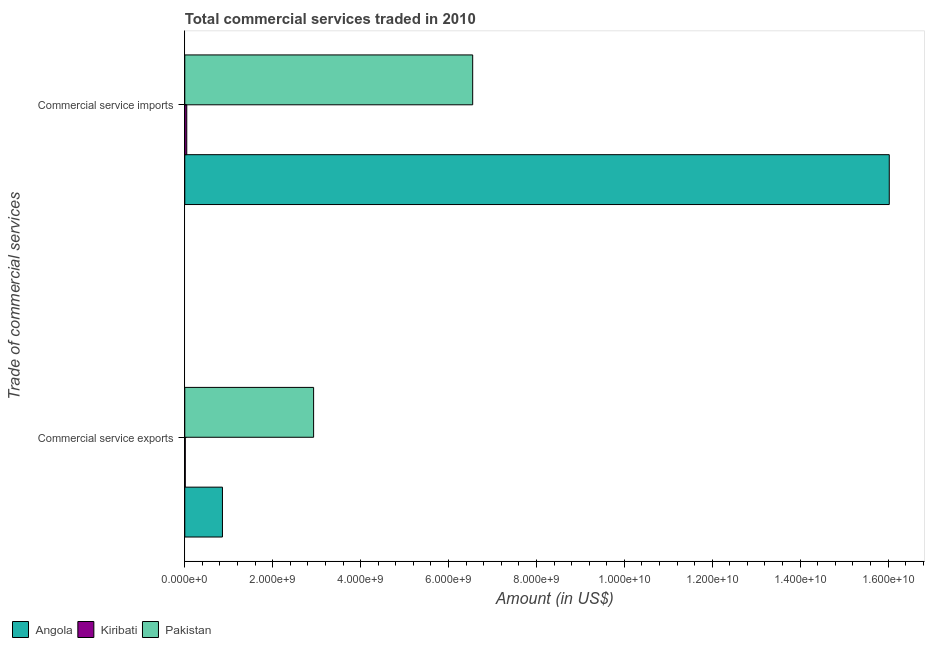How many different coloured bars are there?
Provide a short and direct response. 3. How many groups of bars are there?
Ensure brevity in your answer.  2. Are the number of bars per tick equal to the number of legend labels?
Your answer should be compact. Yes. How many bars are there on the 1st tick from the top?
Ensure brevity in your answer.  3. How many bars are there on the 2nd tick from the bottom?
Ensure brevity in your answer.  3. What is the label of the 2nd group of bars from the top?
Your answer should be very brief. Commercial service exports. What is the amount of commercial service exports in Pakistan?
Give a very brief answer. 2.93e+09. Across all countries, what is the maximum amount of commercial service imports?
Provide a succinct answer. 1.60e+1. Across all countries, what is the minimum amount of commercial service exports?
Ensure brevity in your answer.  1.10e+07. In which country was the amount of commercial service exports maximum?
Ensure brevity in your answer.  Pakistan. In which country was the amount of commercial service exports minimum?
Keep it short and to the point. Kiribati. What is the total amount of commercial service imports in the graph?
Provide a succinct answer. 2.26e+1. What is the difference between the amount of commercial service exports in Pakistan and that in Kiribati?
Your answer should be compact. 2.92e+09. What is the difference between the amount of commercial service imports in Pakistan and the amount of commercial service exports in Angola?
Your response must be concise. 5.69e+09. What is the average amount of commercial service imports per country?
Keep it short and to the point. 7.54e+09. What is the difference between the amount of commercial service imports and amount of commercial service exports in Pakistan?
Your answer should be very brief. 3.62e+09. What is the ratio of the amount of commercial service imports in Angola to that in Pakistan?
Provide a short and direct response. 2.45. In how many countries, is the amount of commercial service imports greater than the average amount of commercial service imports taken over all countries?
Keep it short and to the point. 1. What does the 1st bar from the top in Commercial service exports represents?
Offer a very short reply. Pakistan. What does the 1st bar from the bottom in Commercial service exports represents?
Your response must be concise. Angola. How many bars are there?
Give a very brief answer. 6. Are the values on the major ticks of X-axis written in scientific E-notation?
Provide a succinct answer. Yes. Does the graph contain grids?
Provide a short and direct response. No. Where does the legend appear in the graph?
Your answer should be very brief. Bottom left. How many legend labels are there?
Provide a succinct answer. 3. How are the legend labels stacked?
Keep it short and to the point. Horizontal. What is the title of the graph?
Give a very brief answer. Total commercial services traded in 2010. Does "El Salvador" appear as one of the legend labels in the graph?
Ensure brevity in your answer.  No. What is the label or title of the Y-axis?
Your answer should be very brief. Trade of commercial services. What is the Amount (in US$) of Angola in Commercial service exports?
Your answer should be very brief. 8.57e+08. What is the Amount (in US$) of Kiribati in Commercial service exports?
Your response must be concise. 1.10e+07. What is the Amount (in US$) of Pakistan in Commercial service exports?
Your response must be concise. 2.93e+09. What is the Amount (in US$) in Angola in Commercial service imports?
Give a very brief answer. 1.60e+1. What is the Amount (in US$) of Kiribati in Commercial service imports?
Ensure brevity in your answer.  4.50e+07. What is the Amount (in US$) of Pakistan in Commercial service imports?
Offer a terse response. 6.55e+09. Across all Trade of commercial services, what is the maximum Amount (in US$) in Angola?
Provide a short and direct response. 1.60e+1. Across all Trade of commercial services, what is the maximum Amount (in US$) in Kiribati?
Your answer should be very brief. 4.50e+07. Across all Trade of commercial services, what is the maximum Amount (in US$) of Pakistan?
Provide a succinct answer. 6.55e+09. Across all Trade of commercial services, what is the minimum Amount (in US$) of Angola?
Give a very brief answer. 8.57e+08. Across all Trade of commercial services, what is the minimum Amount (in US$) in Kiribati?
Your answer should be very brief. 1.10e+07. Across all Trade of commercial services, what is the minimum Amount (in US$) in Pakistan?
Your response must be concise. 2.93e+09. What is the total Amount (in US$) of Angola in the graph?
Provide a short and direct response. 1.69e+1. What is the total Amount (in US$) in Kiribati in the graph?
Keep it short and to the point. 5.60e+07. What is the total Amount (in US$) in Pakistan in the graph?
Your answer should be compact. 9.48e+09. What is the difference between the Amount (in US$) in Angola in Commercial service exports and that in Commercial service imports?
Provide a succinct answer. -1.52e+1. What is the difference between the Amount (in US$) of Kiribati in Commercial service exports and that in Commercial service imports?
Keep it short and to the point. -3.41e+07. What is the difference between the Amount (in US$) in Pakistan in Commercial service exports and that in Commercial service imports?
Provide a short and direct response. -3.62e+09. What is the difference between the Amount (in US$) in Angola in Commercial service exports and the Amount (in US$) in Kiribati in Commercial service imports?
Your answer should be compact. 8.12e+08. What is the difference between the Amount (in US$) of Angola in Commercial service exports and the Amount (in US$) of Pakistan in Commercial service imports?
Offer a terse response. -5.69e+09. What is the difference between the Amount (in US$) in Kiribati in Commercial service exports and the Amount (in US$) in Pakistan in Commercial service imports?
Your response must be concise. -6.54e+09. What is the average Amount (in US$) in Angola per Trade of commercial services?
Your response must be concise. 8.44e+09. What is the average Amount (in US$) of Kiribati per Trade of commercial services?
Offer a terse response. 2.80e+07. What is the average Amount (in US$) in Pakistan per Trade of commercial services?
Offer a very short reply. 4.74e+09. What is the difference between the Amount (in US$) in Angola and Amount (in US$) in Kiribati in Commercial service exports?
Give a very brief answer. 8.46e+08. What is the difference between the Amount (in US$) in Angola and Amount (in US$) in Pakistan in Commercial service exports?
Offer a very short reply. -2.07e+09. What is the difference between the Amount (in US$) of Kiribati and Amount (in US$) of Pakistan in Commercial service exports?
Ensure brevity in your answer.  -2.92e+09. What is the difference between the Amount (in US$) of Angola and Amount (in US$) of Kiribati in Commercial service imports?
Your answer should be compact. 1.60e+1. What is the difference between the Amount (in US$) in Angola and Amount (in US$) in Pakistan in Commercial service imports?
Provide a short and direct response. 9.48e+09. What is the difference between the Amount (in US$) of Kiribati and Amount (in US$) of Pakistan in Commercial service imports?
Ensure brevity in your answer.  -6.50e+09. What is the ratio of the Amount (in US$) of Angola in Commercial service exports to that in Commercial service imports?
Provide a short and direct response. 0.05. What is the ratio of the Amount (in US$) in Kiribati in Commercial service exports to that in Commercial service imports?
Provide a succinct answer. 0.24. What is the ratio of the Amount (in US$) of Pakistan in Commercial service exports to that in Commercial service imports?
Your response must be concise. 0.45. What is the difference between the highest and the second highest Amount (in US$) of Angola?
Provide a short and direct response. 1.52e+1. What is the difference between the highest and the second highest Amount (in US$) of Kiribati?
Give a very brief answer. 3.41e+07. What is the difference between the highest and the second highest Amount (in US$) of Pakistan?
Give a very brief answer. 3.62e+09. What is the difference between the highest and the lowest Amount (in US$) in Angola?
Ensure brevity in your answer.  1.52e+1. What is the difference between the highest and the lowest Amount (in US$) in Kiribati?
Your response must be concise. 3.41e+07. What is the difference between the highest and the lowest Amount (in US$) of Pakistan?
Provide a succinct answer. 3.62e+09. 